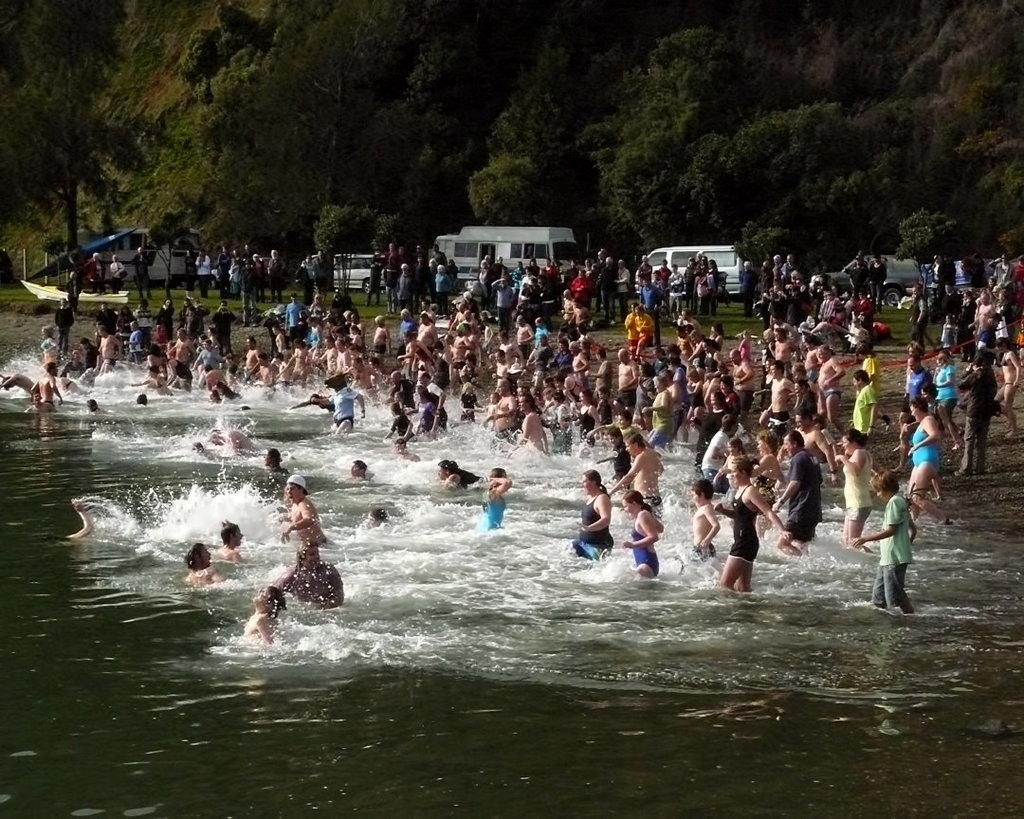What are the persons in the image doing? There are persons in the water and persons standing on the ground. What can be seen on the road in the image? There are cars on the road. What type of natural elements are visible in the image? There are trees visible in the image. How many ants are crawling on the nose of the person standing on the ground? There are no ants visible in the image, and no person's nose is shown. 